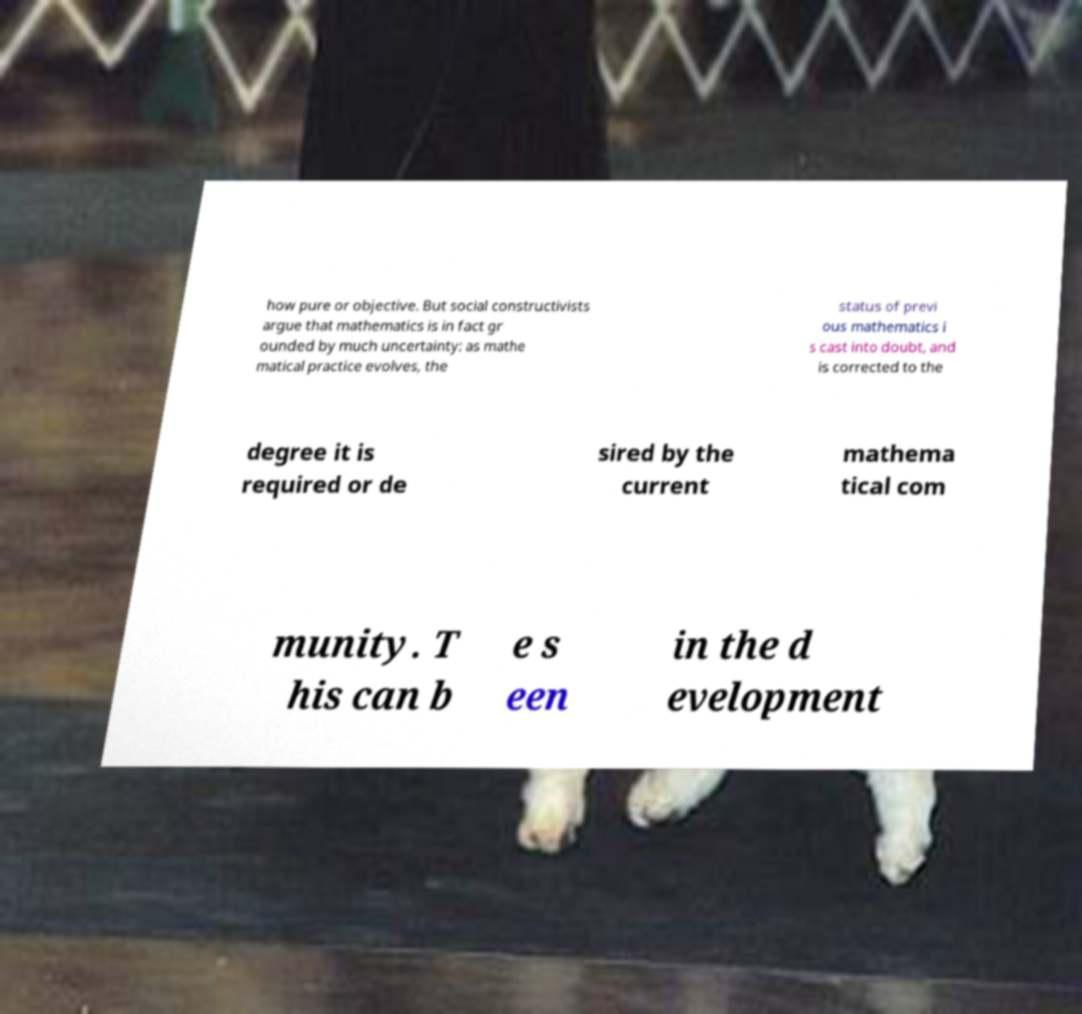For documentation purposes, I need the text within this image transcribed. Could you provide that? how pure or objective. But social constructivists argue that mathematics is in fact gr ounded by much uncertainty: as mathe matical practice evolves, the status of previ ous mathematics i s cast into doubt, and is corrected to the degree it is required or de sired by the current mathema tical com munity. T his can b e s een in the d evelopment 